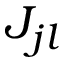Convert formula to latex. <formula><loc_0><loc_0><loc_500><loc_500>J _ { j l }</formula> 